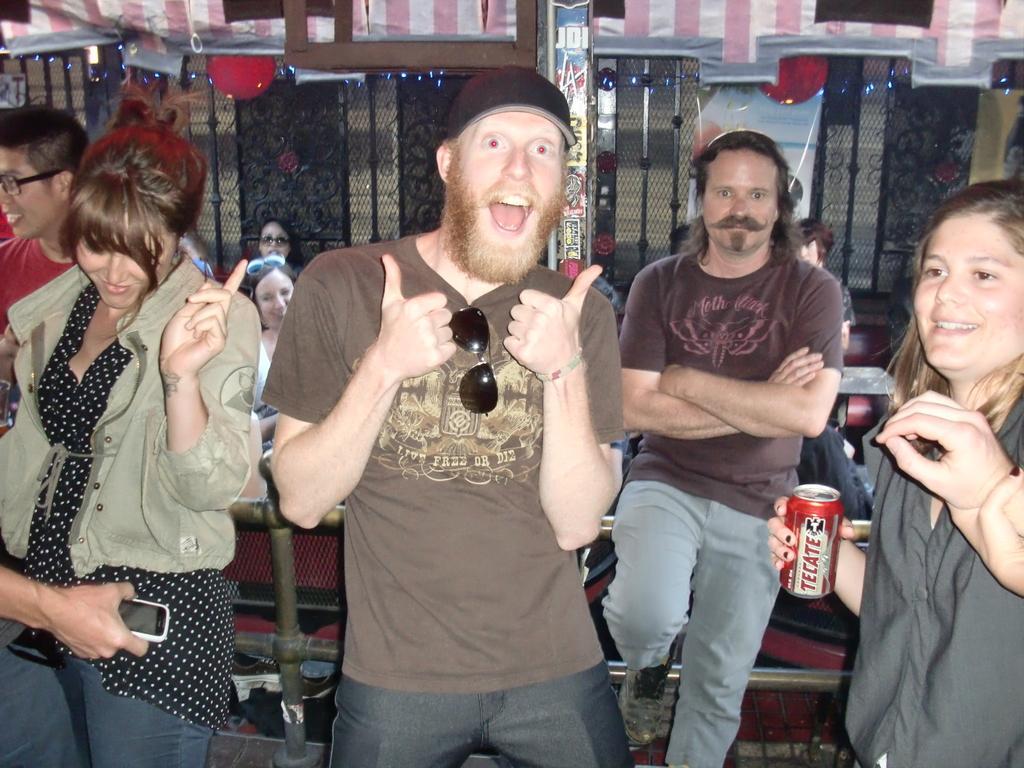How would you summarize this image in a sentence or two? In this image there is a person wearing a cap. Right side there is a woman holding a coke can. There are people standing. Left side a person's hand is visible. He is holding a mobile. There is a fence on the floor. Behind there are people. There are decorative items attached to the wall. Middle of the image there is a pillar. 